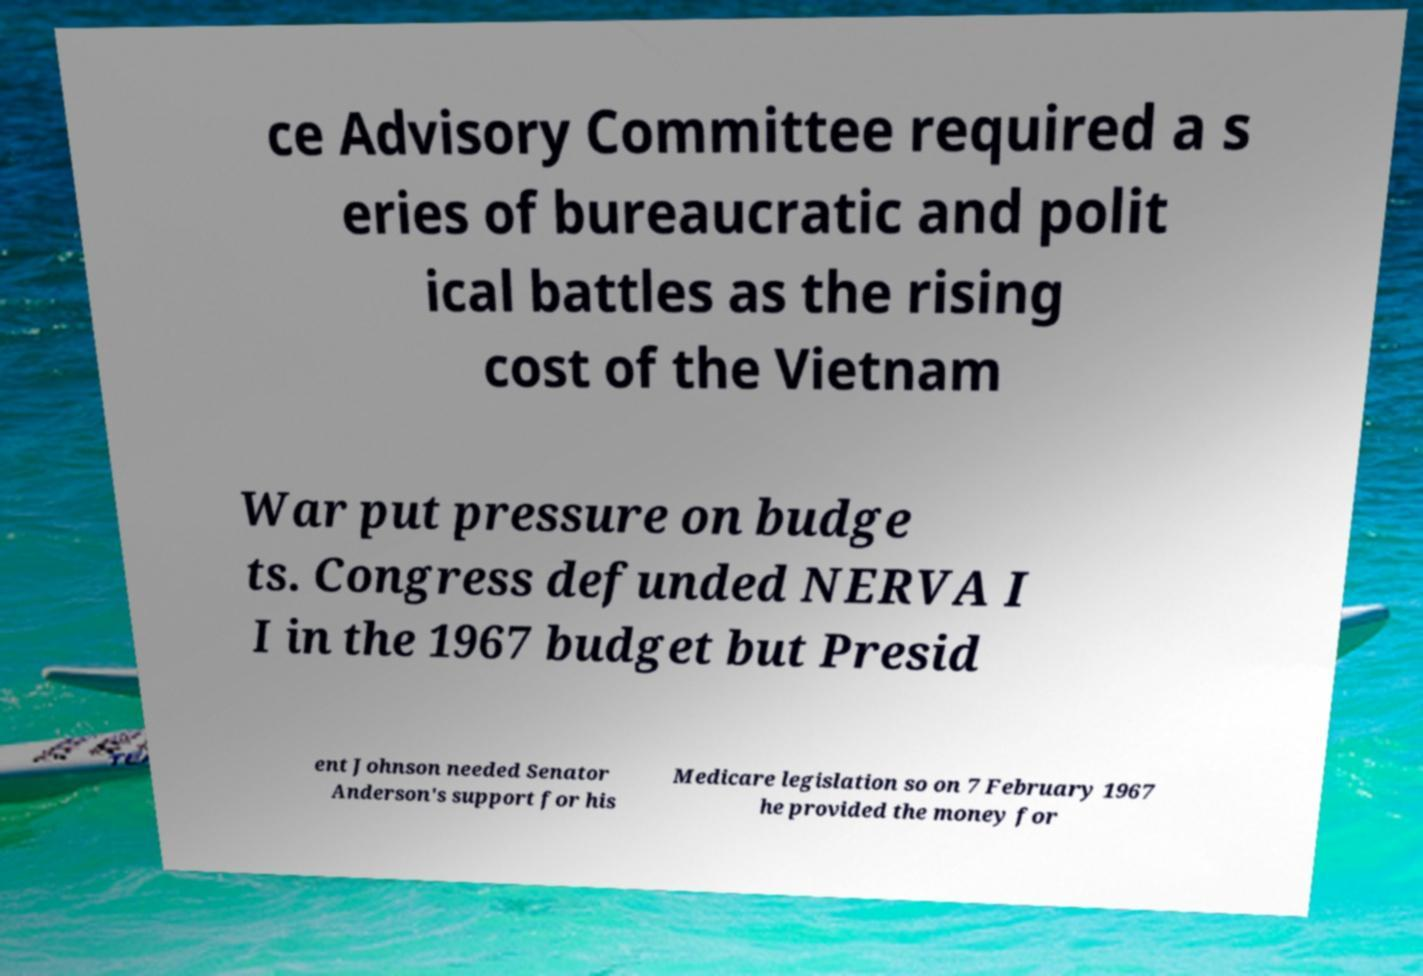I need the written content from this picture converted into text. Can you do that? ce Advisory Committee required a s eries of bureaucratic and polit ical battles as the rising cost of the Vietnam War put pressure on budge ts. Congress defunded NERVA I I in the 1967 budget but Presid ent Johnson needed Senator Anderson's support for his Medicare legislation so on 7 February 1967 he provided the money for 